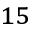<formula> <loc_0><loc_0><loc_500><loc_500>^ { 1 5 }</formula> 